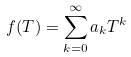<formula> <loc_0><loc_0><loc_500><loc_500>f ( T ) = \sum _ { k = 0 } ^ { \infty } a _ { k } T ^ { k }</formula> 